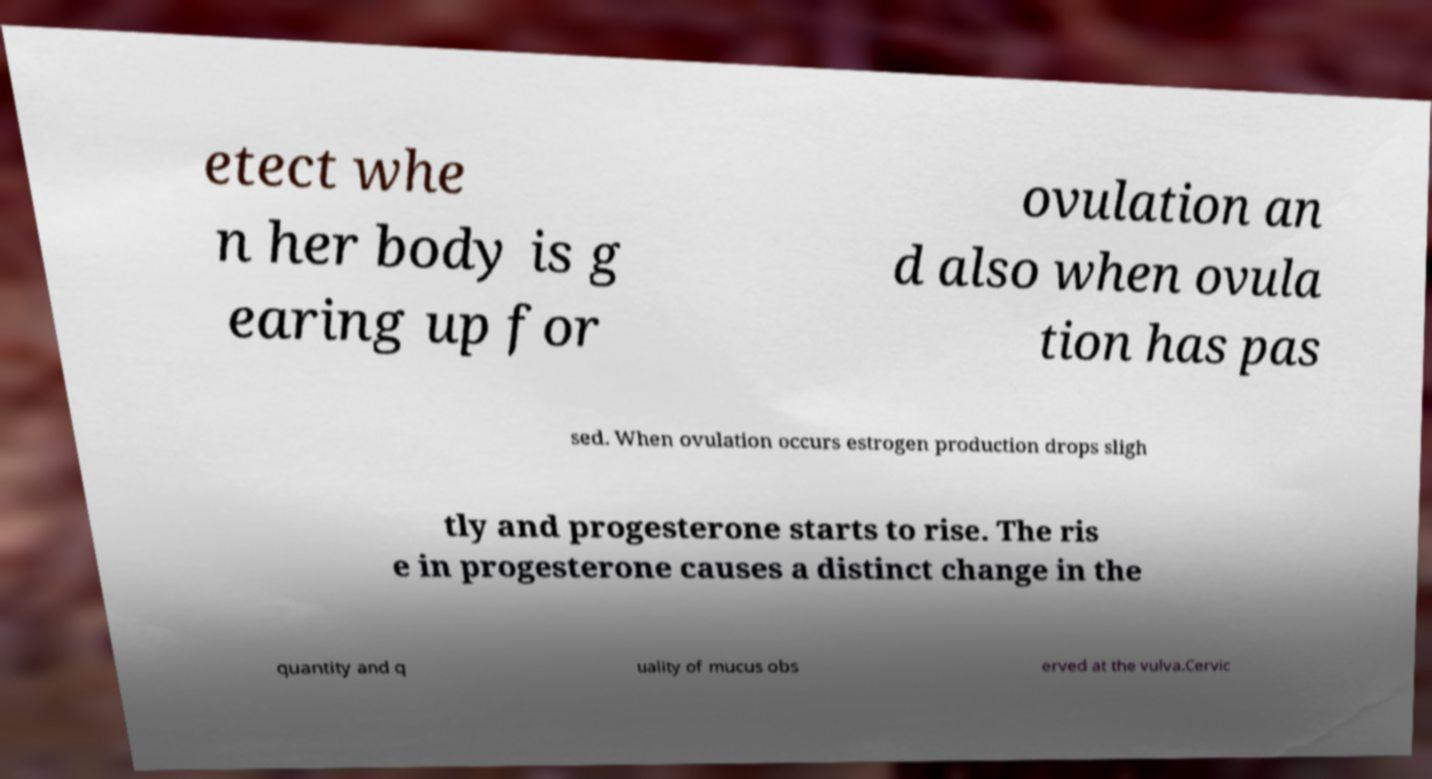There's text embedded in this image that I need extracted. Can you transcribe it verbatim? etect whe n her body is g earing up for ovulation an d also when ovula tion has pas sed. When ovulation occurs estrogen production drops sligh tly and progesterone starts to rise. The ris e in progesterone causes a distinct change in the quantity and q uality of mucus obs erved at the vulva.Cervic 